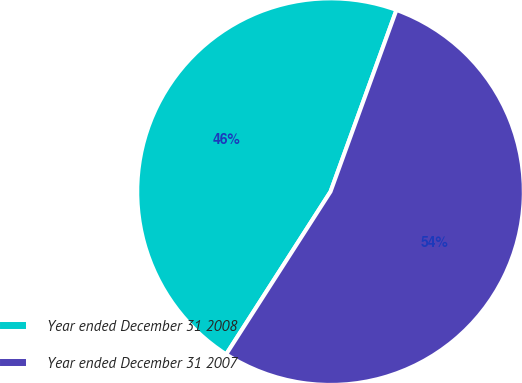Convert chart to OTSL. <chart><loc_0><loc_0><loc_500><loc_500><pie_chart><fcel>Year ended December 31 2008<fcel>Year ended December 31 2007<nl><fcel>46.46%<fcel>53.54%<nl></chart> 